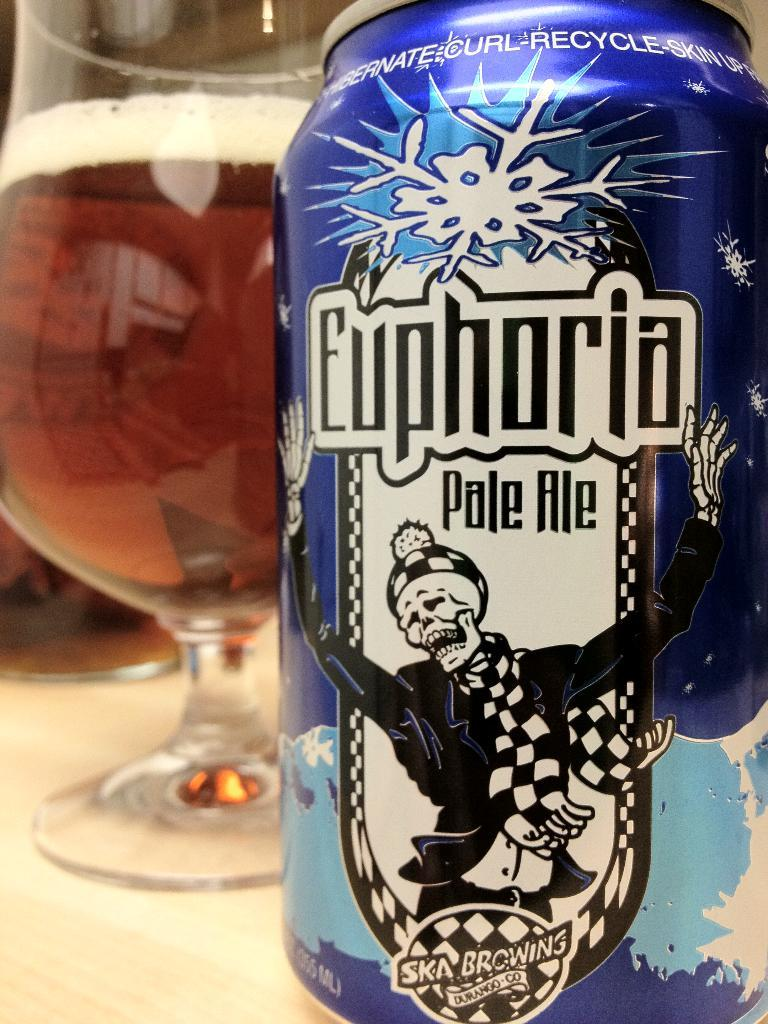<image>
Create a compact narrative representing the image presented. A can of Euphoria pale ale is on a table next to a filled glass. 